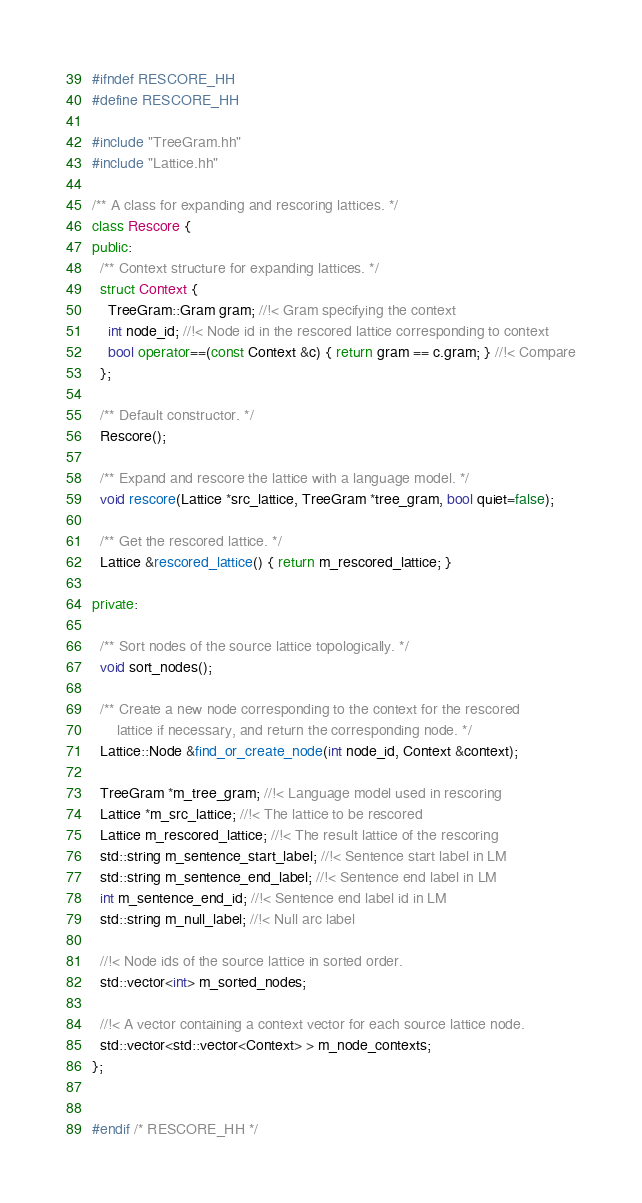<code> <loc_0><loc_0><loc_500><loc_500><_C++_>#ifndef RESCORE_HH
#define RESCORE_HH

#include "TreeGram.hh"
#include "Lattice.hh"

/** A class for expanding and rescoring lattices. */
class Rescore {
public:
  /** Context structure for expanding lattices. */
  struct Context {
    TreeGram::Gram gram; //!< Gram specifying the context
    int node_id; //!< Node id in the rescored lattice corresponding to context
    bool operator==(const Context &c) { return gram == c.gram; } //!< Compare
  };

  /** Default constructor. */
  Rescore();

  /** Expand and rescore the lattice with a language model. */
  void rescore(Lattice *src_lattice, TreeGram *tree_gram, bool quiet=false);

  /** Get the rescored lattice. */
  Lattice &rescored_lattice() { return m_rescored_lattice; }

private:

  /** Sort nodes of the source lattice topologically. */
  void sort_nodes();

  /** Create a new node corresponding to the context for the rescored
      lattice if necessary, and return the corresponding node. */
  Lattice::Node &find_or_create_node(int node_id, Context &context);

  TreeGram *m_tree_gram; //!< Language model used in rescoring
  Lattice *m_src_lattice; //!< The lattice to be rescored
  Lattice m_rescored_lattice; //!< The result lattice of the rescoring
  std::string m_sentence_start_label; //!< Sentence start label in LM
  std::string m_sentence_end_label; //!< Sentence end label in LM
  int m_sentence_end_id; //!< Sentence end label id in LM
  std::string m_null_label; //!< Null arc label

  //!< Node ids of the source lattice in sorted order.
  std::vector<int> m_sorted_nodes;

  //!< A vector containing a context vector for each source lattice node.
  std::vector<std::vector<Context> > m_node_contexts;
};


#endif /* RESCORE_HH */
</code> 